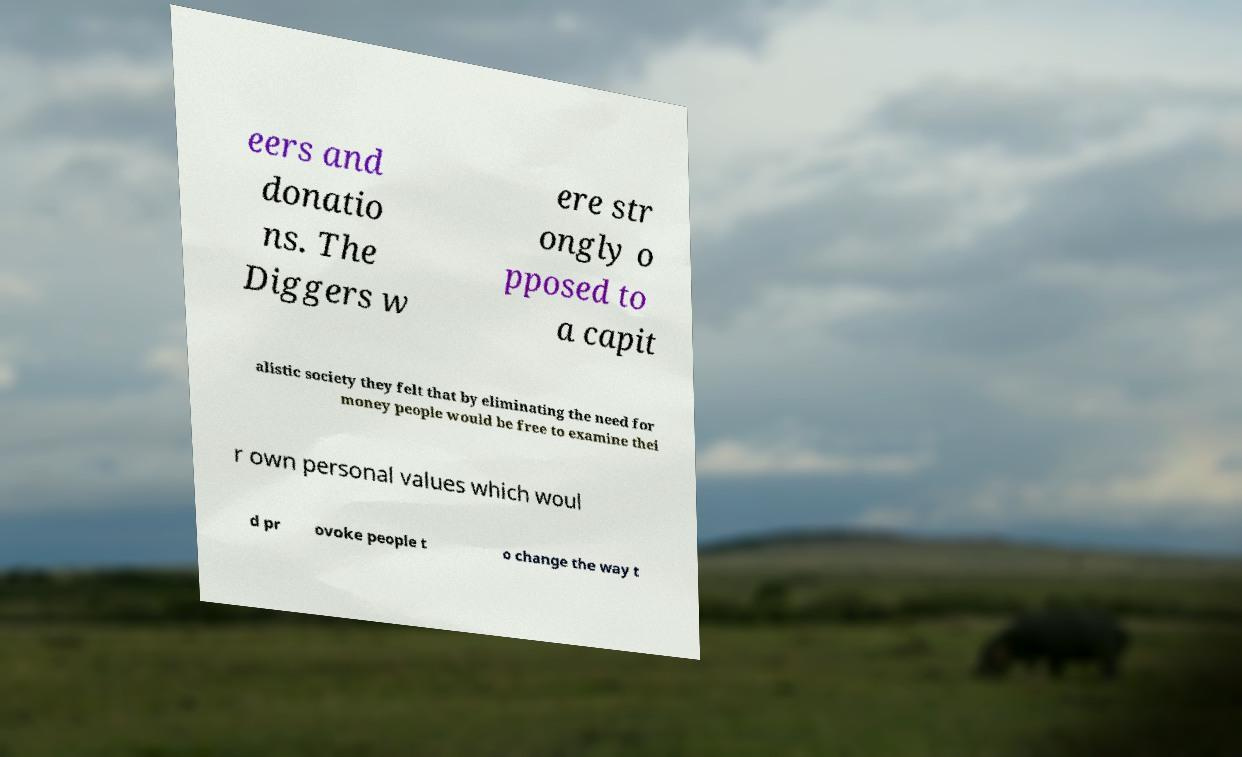Could you assist in decoding the text presented in this image and type it out clearly? eers and donatio ns. The Diggers w ere str ongly o pposed to a capit alistic society they felt that by eliminating the need for money people would be free to examine thei r own personal values which woul d pr ovoke people t o change the way t 